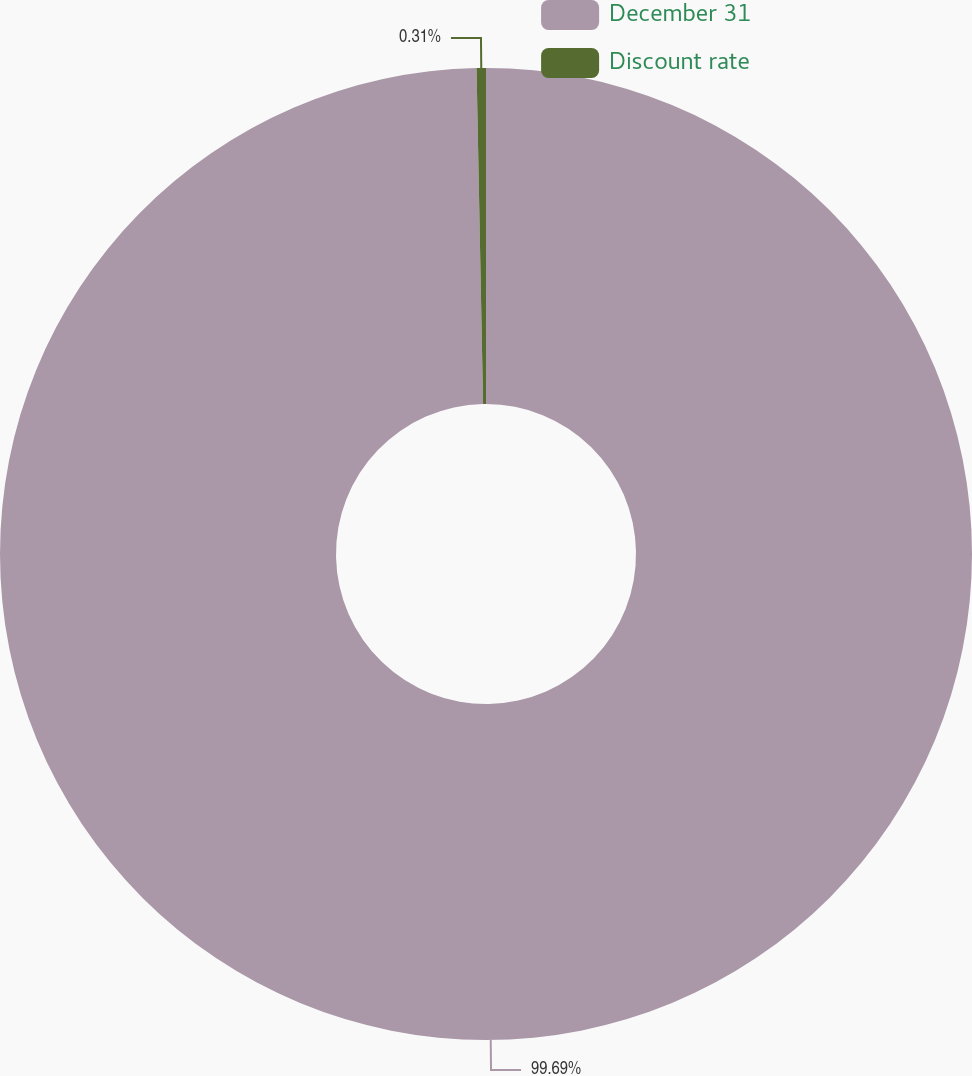Convert chart. <chart><loc_0><loc_0><loc_500><loc_500><pie_chart><fcel>December 31<fcel>Discount rate<nl><fcel>99.69%<fcel>0.31%<nl></chart> 